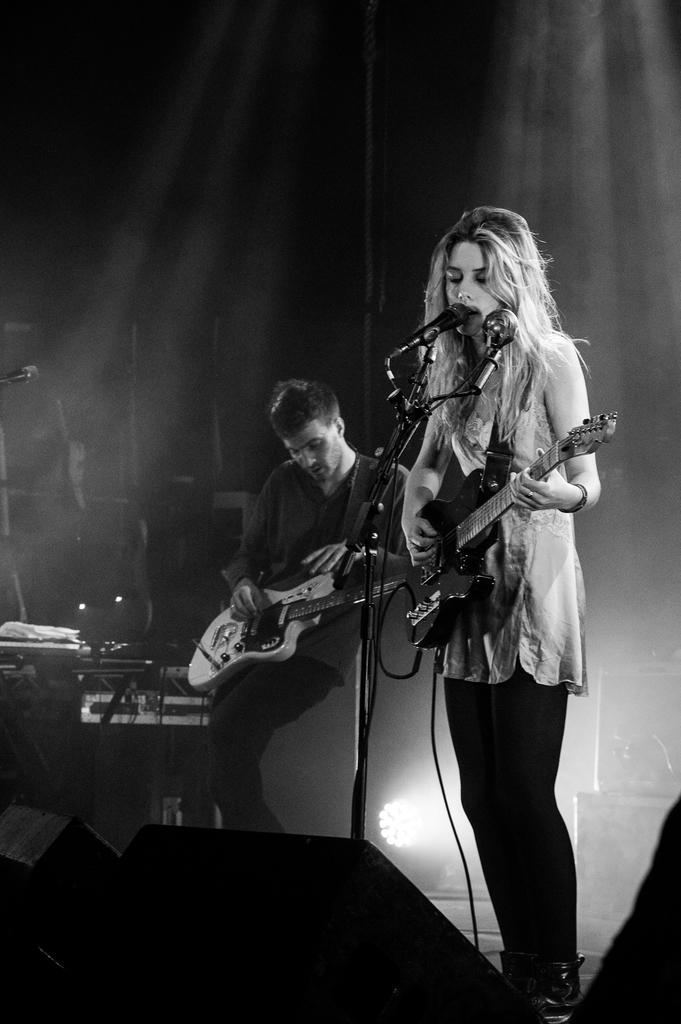How many people are in the image? There are two people in the image. What are the two people doing in the image? The two people are standing and playing guitar. What object is in front of the two people? There is a microphone in front of them. What type of juice can be seen in the image? There is no juice present in the image. What station are the two people playing guitar at in the image? There is no indication of a specific station or location in the image. 